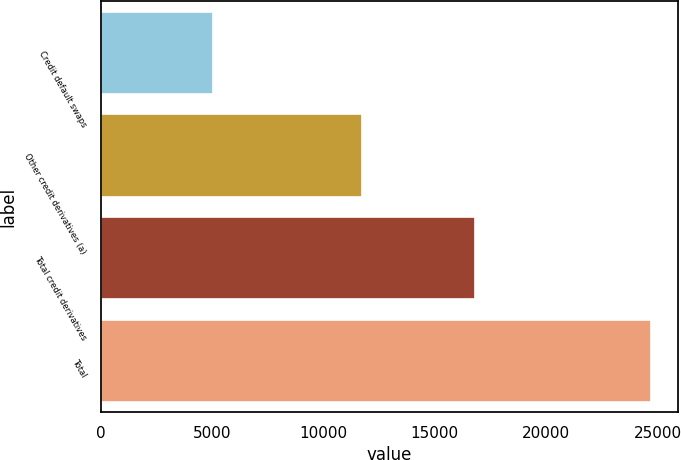<chart> <loc_0><loc_0><loc_500><loc_500><bar_chart><fcel>Credit default swaps<fcel>Other credit derivatives (a)<fcel>Total credit derivatives<fcel>Total<nl><fcel>5045<fcel>11747<fcel>16792<fcel>24707<nl></chart> 